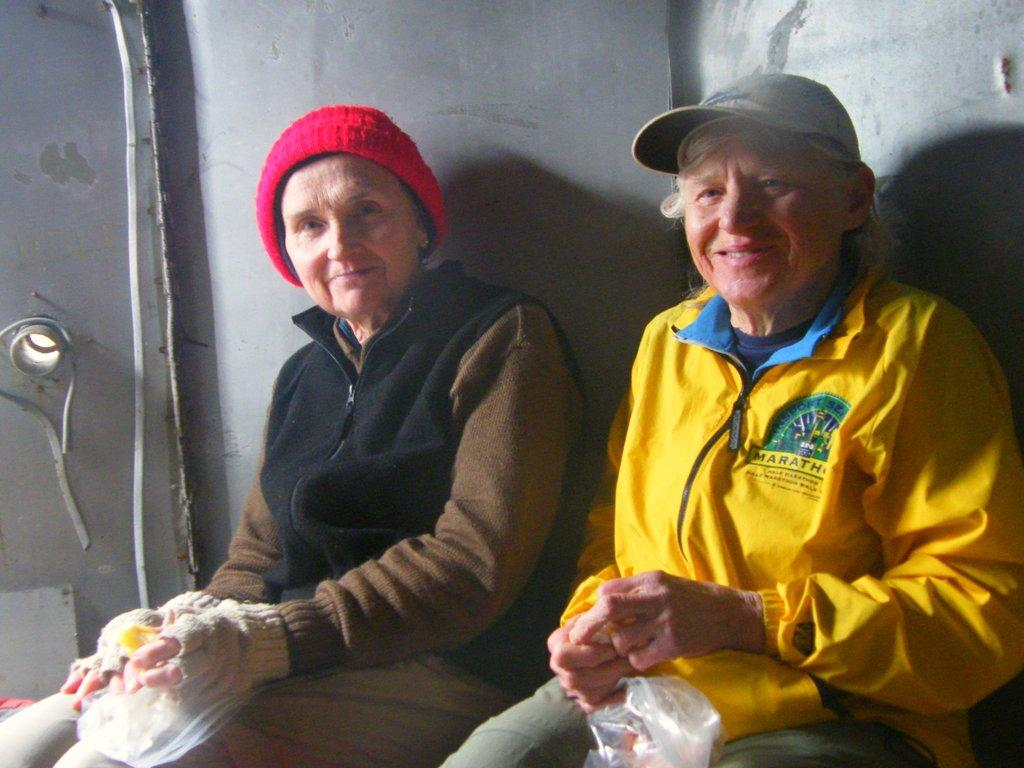How many people are in the image? There are two old women in the image. What are the women wearing on their upper bodies? The women are wearing jackets. What are the women wearing on their heads? The women are wearing caps. What are the women doing in the image? The women are sitting in the image. What expressions do the women have? The women are smiling. What are the women holding in their hands? The women are holding covers in their hands. What type of bread can be seen in the image? There is no bread present in the image. What color are the trousers worn by the women in the image? The provided facts do not mention the color or presence of trousers; only jackets and caps are mentioned. 